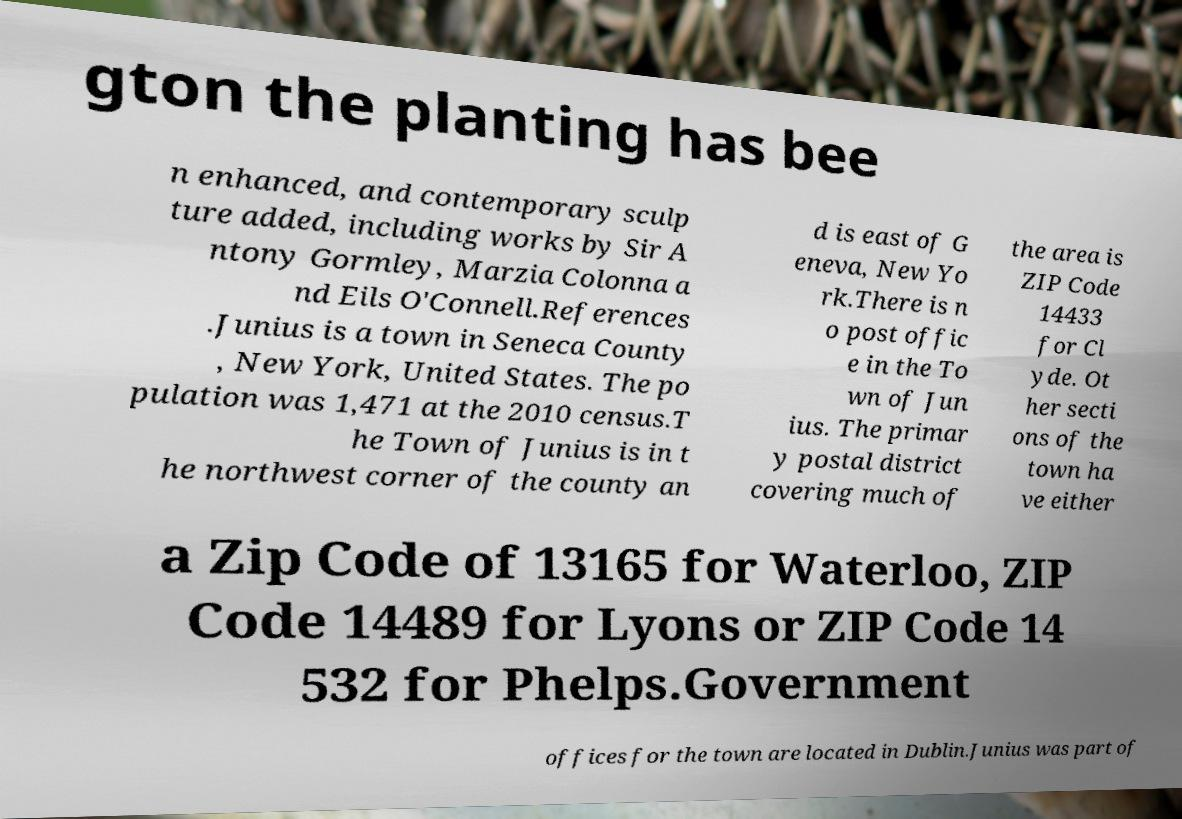Can you read and provide the text displayed in the image?This photo seems to have some interesting text. Can you extract and type it out for me? gton the planting has bee n enhanced, and contemporary sculp ture added, including works by Sir A ntony Gormley, Marzia Colonna a nd Eils O'Connell.References .Junius is a town in Seneca County , New York, United States. The po pulation was 1,471 at the 2010 census.T he Town of Junius is in t he northwest corner of the county an d is east of G eneva, New Yo rk.There is n o post offic e in the To wn of Jun ius. The primar y postal district covering much of the area is ZIP Code 14433 for Cl yde. Ot her secti ons of the town ha ve either a Zip Code of 13165 for Waterloo, ZIP Code 14489 for Lyons or ZIP Code 14 532 for Phelps.Government offices for the town are located in Dublin.Junius was part of 